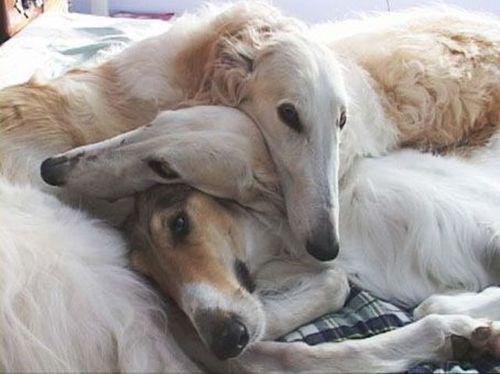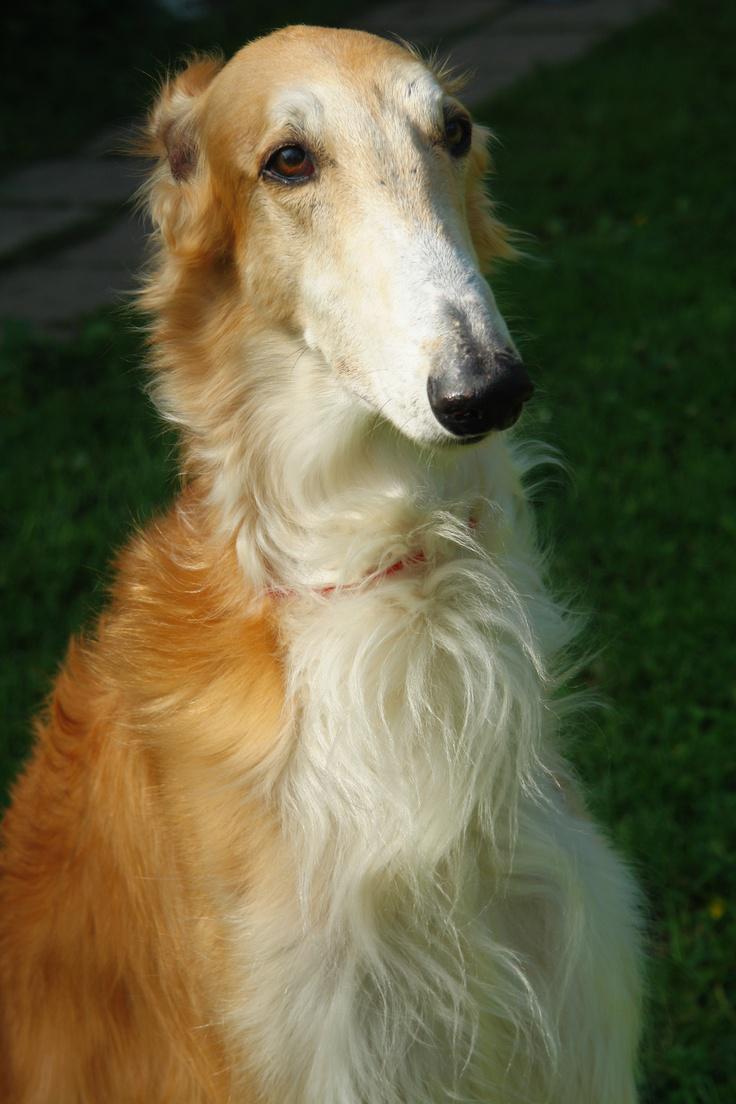The first image is the image on the left, the second image is the image on the right. Analyze the images presented: Is the assertion "An image includes at least one person standing behind a standing afghan hound outdoors." valid? Answer yes or no. No. The first image is the image on the left, the second image is the image on the right. For the images shown, is this caption "There are exactly two dogs in total." true? Answer yes or no. No. 